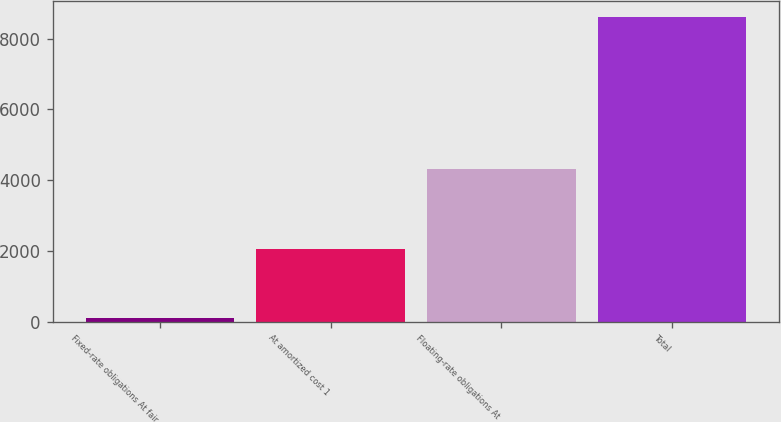Convert chart. <chart><loc_0><loc_0><loc_500><loc_500><bar_chart><fcel>Fixed-rate obligations At fair<fcel>At amortized cost 1<fcel>Floating-rate obligations At<fcel>Total<nl><fcel>94<fcel>2047<fcel>4305<fcel>8626<nl></chart> 